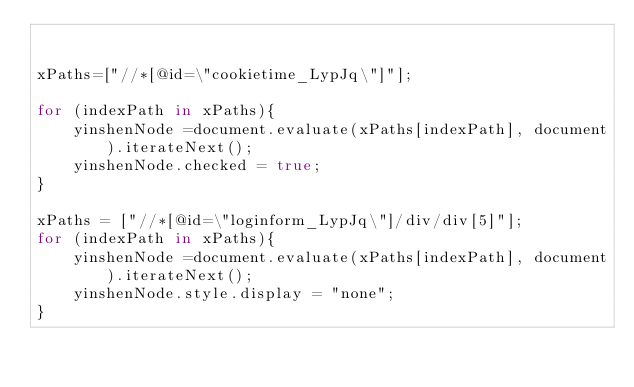<code> <loc_0><loc_0><loc_500><loc_500><_JavaScript_>

xPaths=["//*[@id=\"cookietime_LypJq\"]"];

for (indexPath in xPaths){
    yinshenNode =document.evaluate(xPaths[indexPath], document).iterateNext();
    yinshenNode.checked = true;
}

xPaths = ["//*[@id=\"loginform_LypJq\"]/div/div[5]"];
for (indexPath in xPaths){
    yinshenNode =document.evaluate(xPaths[indexPath], document).iterateNext();
    yinshenNode.style.display = "none";
}</code> 